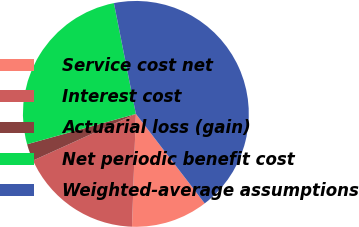Convert chart. <chart><loc_0><loc_0><loc_500><loc_500><pie_chart><fcel>Service cost net<fcel>Interest cost<fcel>Actuarial loss (gain)<fcel>Net periodic benefit cost<fcel>Weighted-average assumptions<nl><fcel>10.98%<fcel>17.68%<fcel>2.44%<fcel>26.22%<fcel>42.68%<nl></chart> 